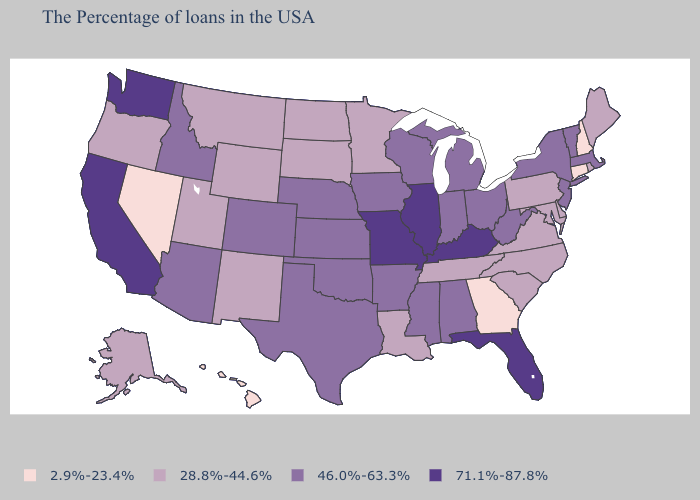Does Missouri have the highest value in the USA?
Write a very short answer. Yes. Does Mississippi have a higher value than Nebraska?
Keep it brief. No. What is the value of South Carolina?
Answer briefly. 28.8%-44.6%. What is the lowest value in the USA?
Concise answer only. 2.9%-23.4%. Does Oklahoma have the same value as North Carolina?
Quick response, please. No. Name the states that have a value in the range 2.9%-23.4%?
Short answer required. New Hampshire, Connecticut, Georgia, Nevada, Hawaii. Is the legend a continuous bar?
Give a very brief answer. No. What is the value of Missouri?
Write a very short answer. 71.1%-87.8%. Does the first symbol in the legend represent the smallest category?
Give a very brief answer. Yes. Name the states that have a value in the range 2.9%-23.4%?
Quick response, please. New Hampshire, Connecticut, Georgia, Nevada, Hawaii. What is the value of Texas?
Keep it brief. 46.0%-63.3%. Which states have the lowest value in the MidWest?
Give a very brief answer. Minnesota, South Dakota, North Dakota. Name the states that have a value in the range 2.9%-23.4%?
Short answer required. New Hampshire, Connecticut, Georgia, Nevada, Hawaii. What is the value of Washington?
Write a very short answer. 71.1%-87.8%. What is the value of Pennsylvania?
Write a very short answer. 28.8%-44.6%. 